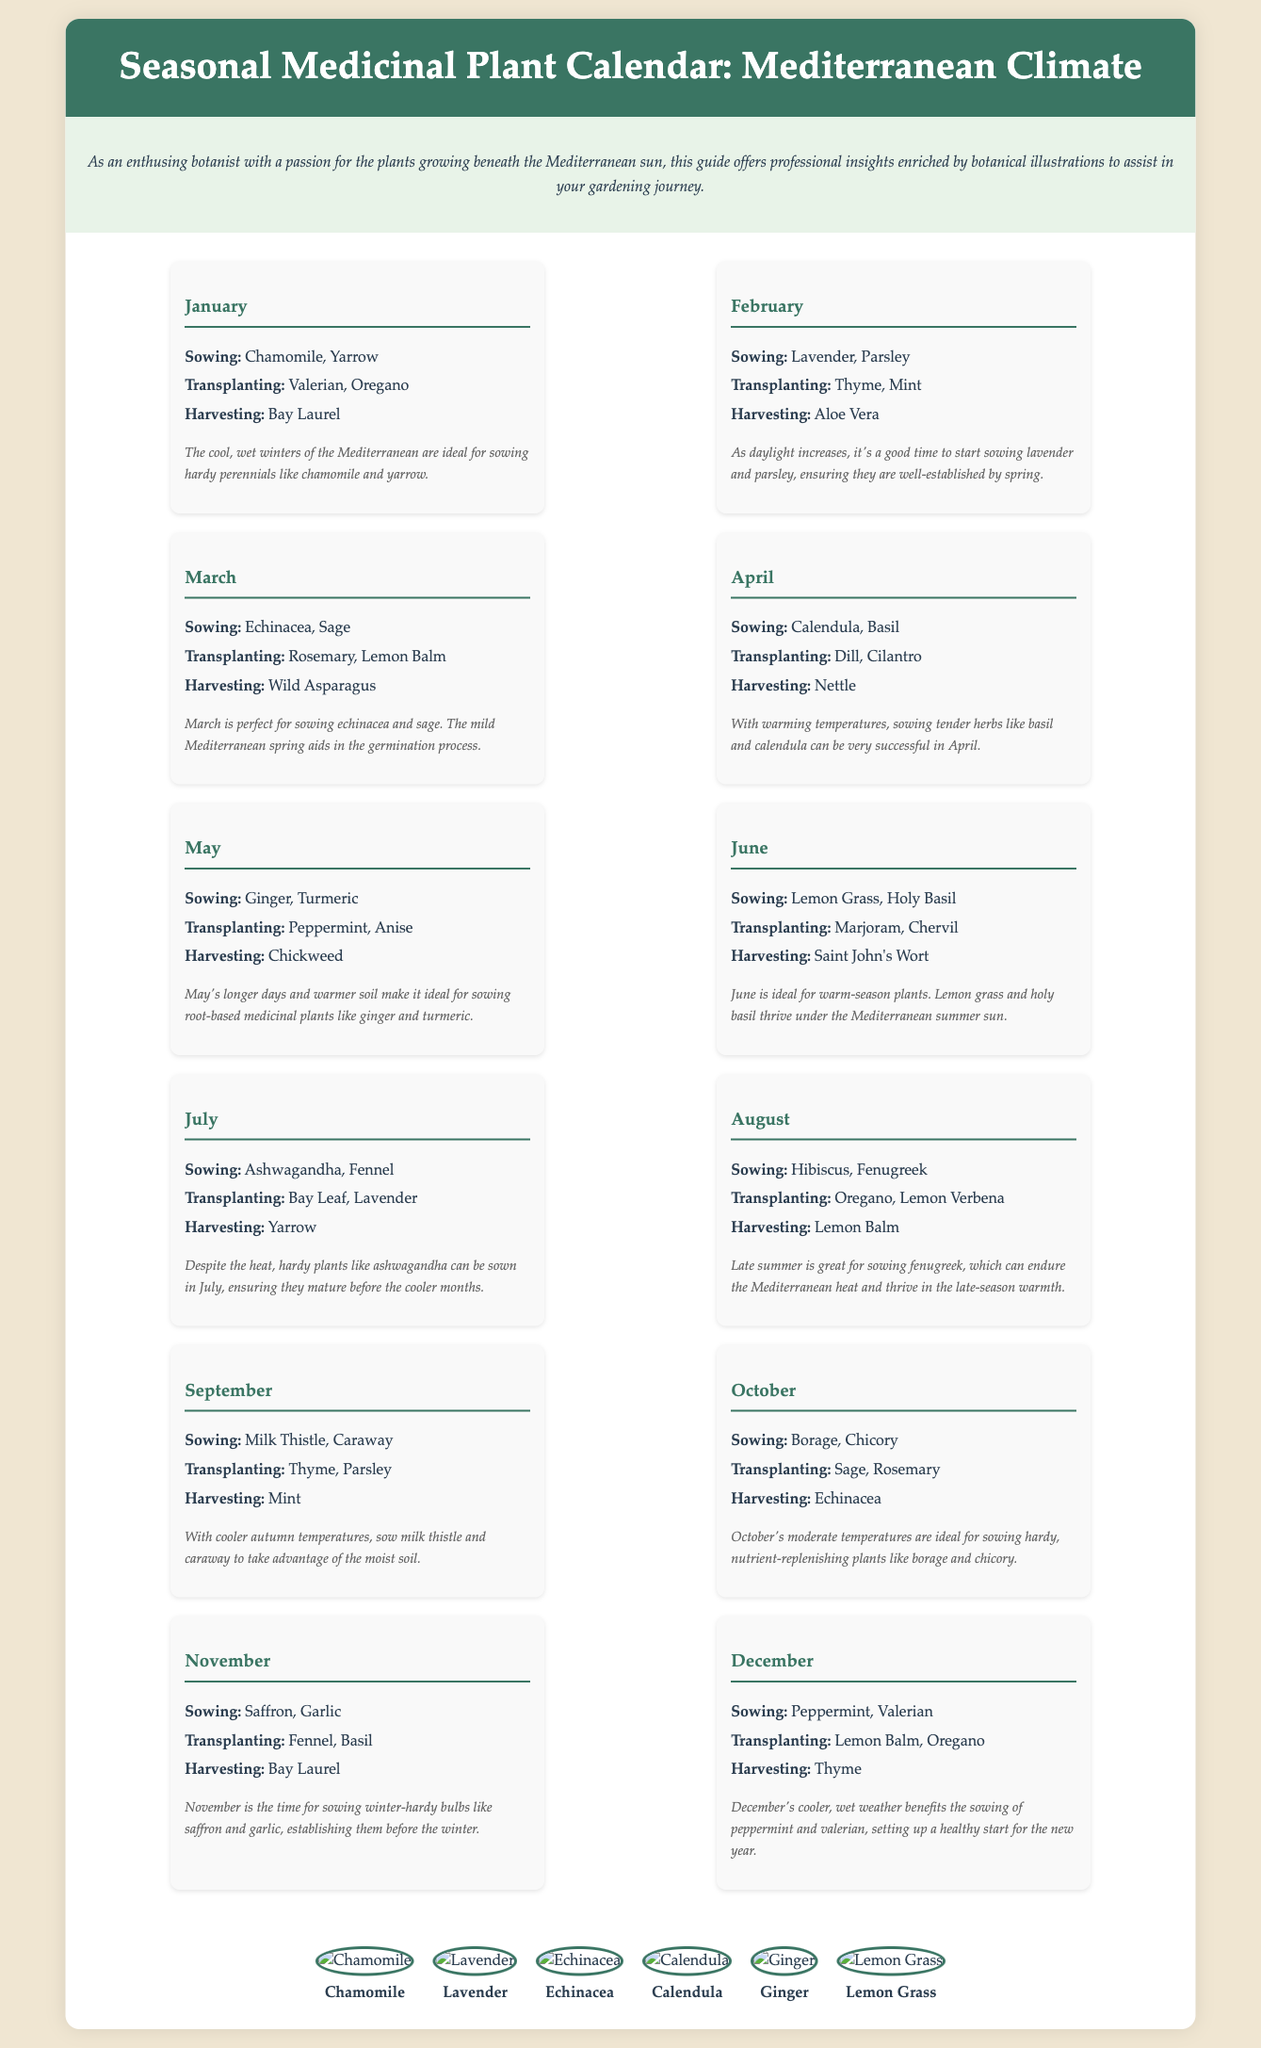What plants are sown in January? The document lists the plants that are sown in January, specifically Chamomile and Yarrow.
Answer: Chamomile, Yarrow When is the ideal month for transplanting Oregano? The document indicates that Oregano should be transplanted in January.
Answer: January Which plant is harvested in August? The document mentions that Lemon Balm is harvested in August.
Answer: Lemon Balm What is a key insight for sowing in March? The document provides an insight that March is perfect for sowing echinacea and sage due to the mild Mediterranean spring.
Answer: Mild Mediterranean spring How many medicinal plants are sown in June? The document lists two plants that are sown in June: Lemongrass and Holy Basil.
Answer: Two Which two plants are noted for harvesting in December? The document states that Thyme and Valerian are harvested in December.
Answer: Thyme, Valerian What is the optimal time for sowing Ginger? According to the document, May is the optimal time for sowing Ginger.
Answer: May In what season are root-based medicinal plants like turmeric sown? The document indicates that May, with longer days and warmer soil, is the season for sowing root-based medicinal plants like turmeric.
Answer: May What type of document is this? The document is a calendar indicating the best times for sowing, transplanting, and harvesting medicinal plants in a Mediterranean climate.
Answer: Calendar 